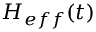Convert formula to latex. <formula><loc_0><loc_0><loc_500><loc_500>H _ { e f f } ( t )</formula> 